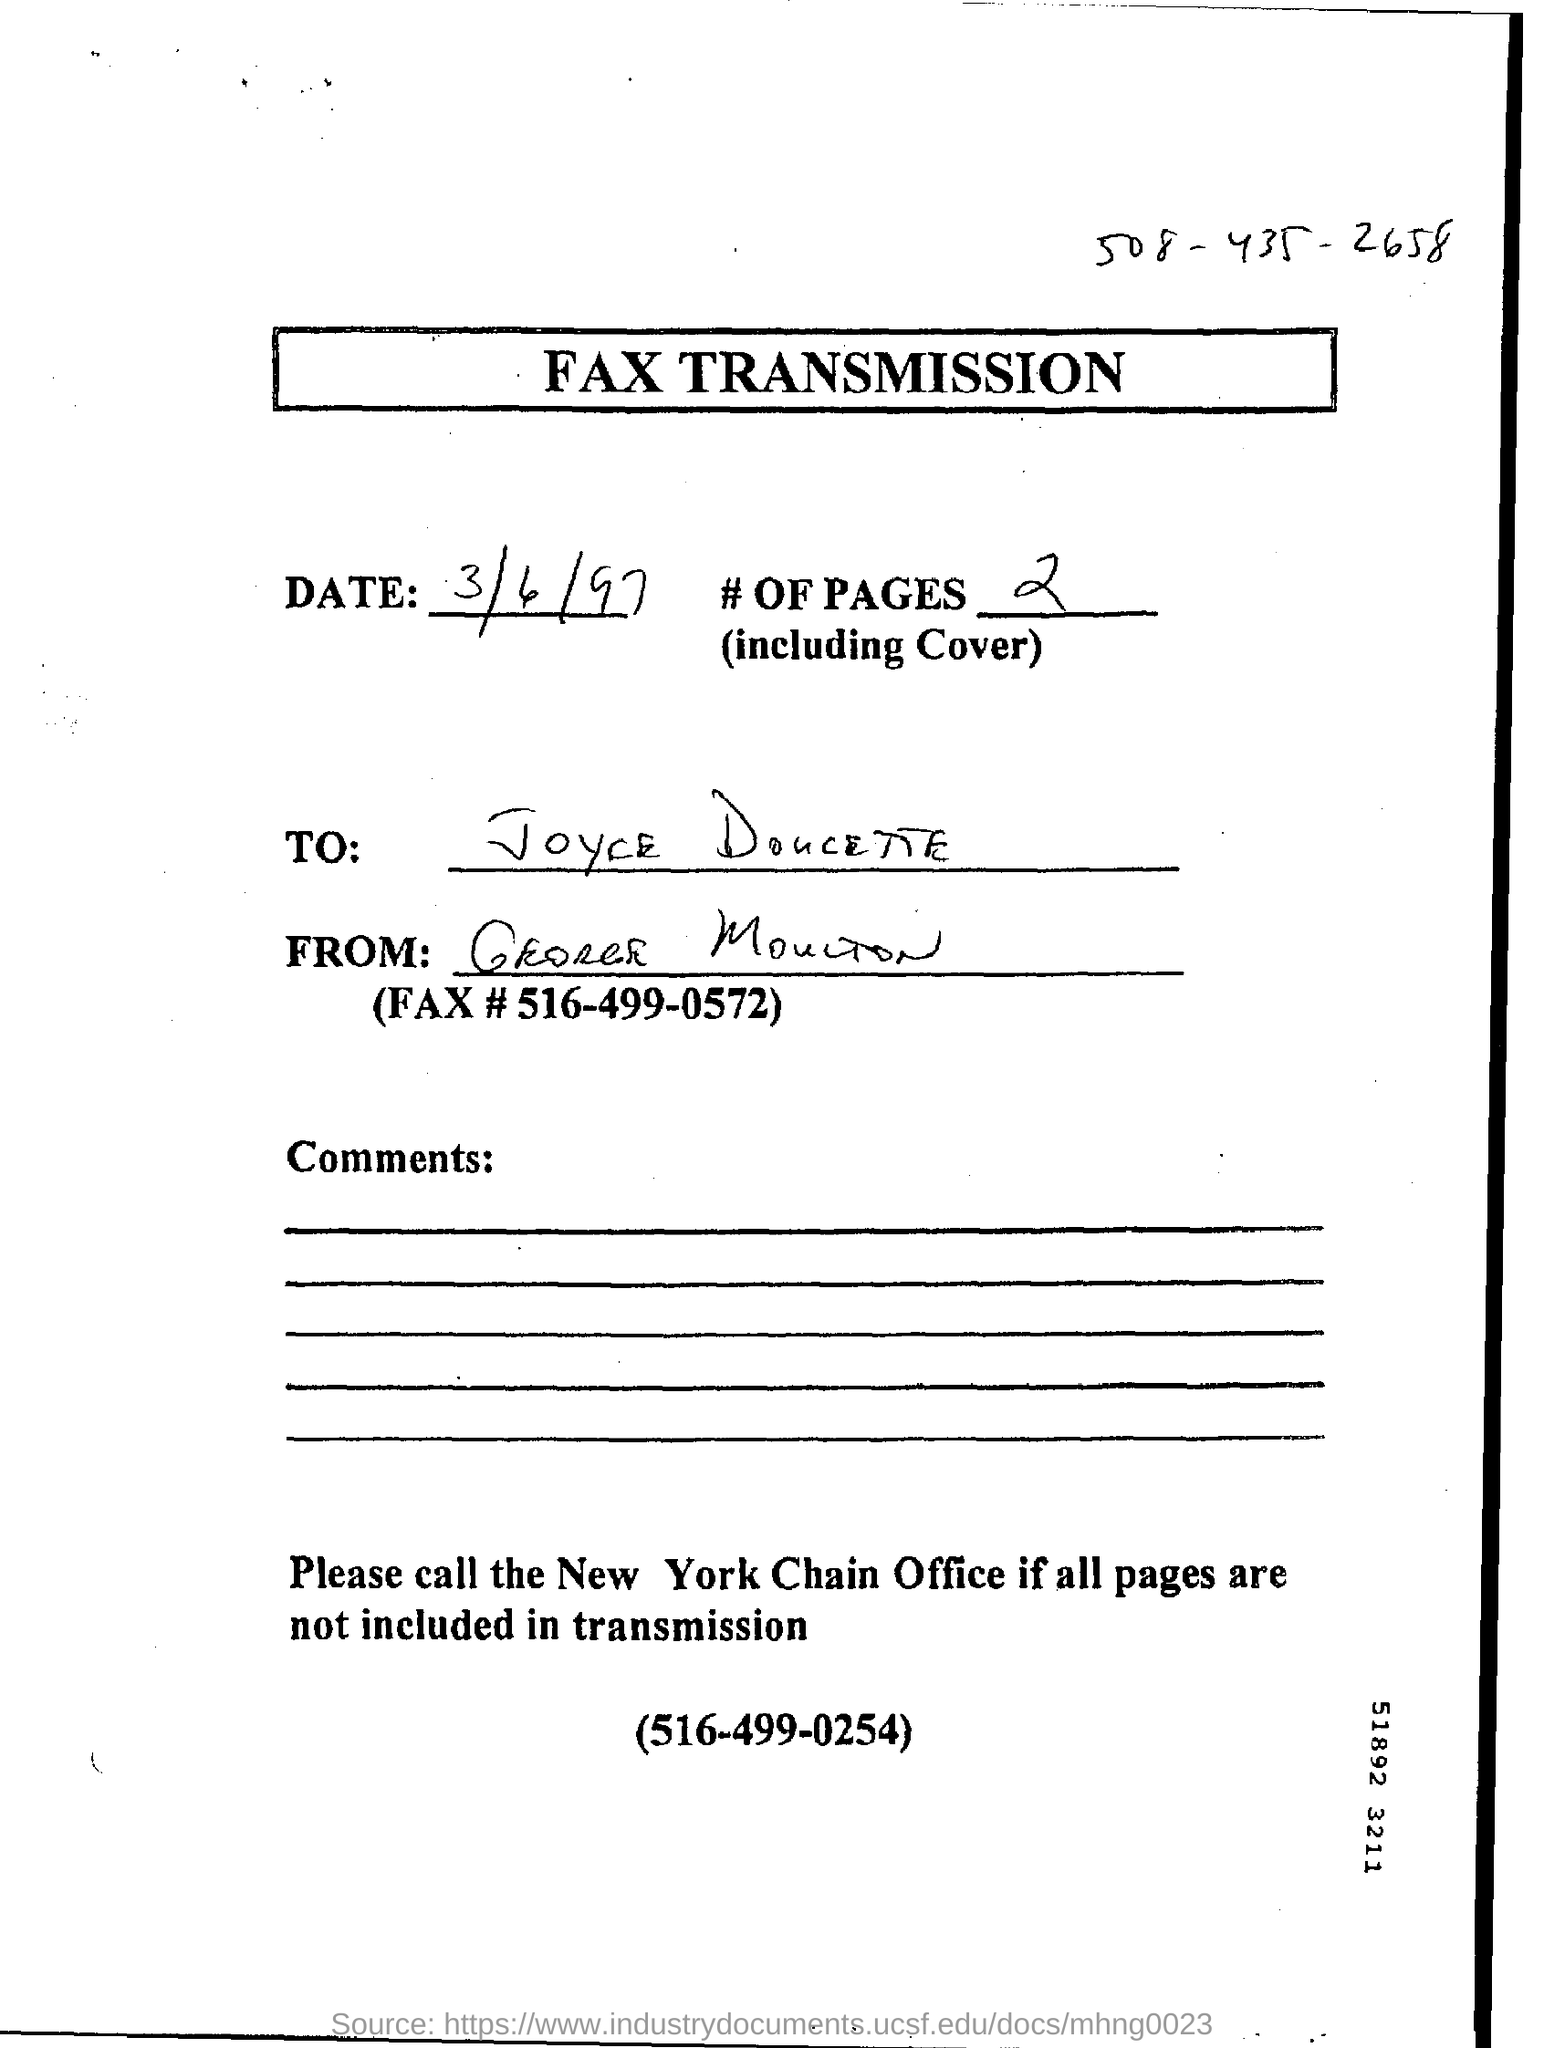What is headline of this document?
Your answer should be compact. FAX TRANSMISSION. What is the date of of document?
Your answer should be compact. 3/6/97. What is # of pages?
Keep it short and to the point. 2. 